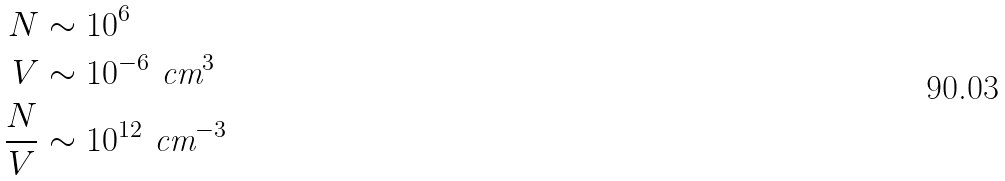Convert formula to latex. <formula><loc_0><loc_0><loc_500><loc_500>N & \sim 1 0 ^ { 6 } \\ V & \sim 1 0 ^ { - 6 } \text { cm} ^ { 3 } \\ \frac { N } { V } & \sim 1 0 ^ { 1 2 } \text { cm} ^ { - 3 }</formula> 